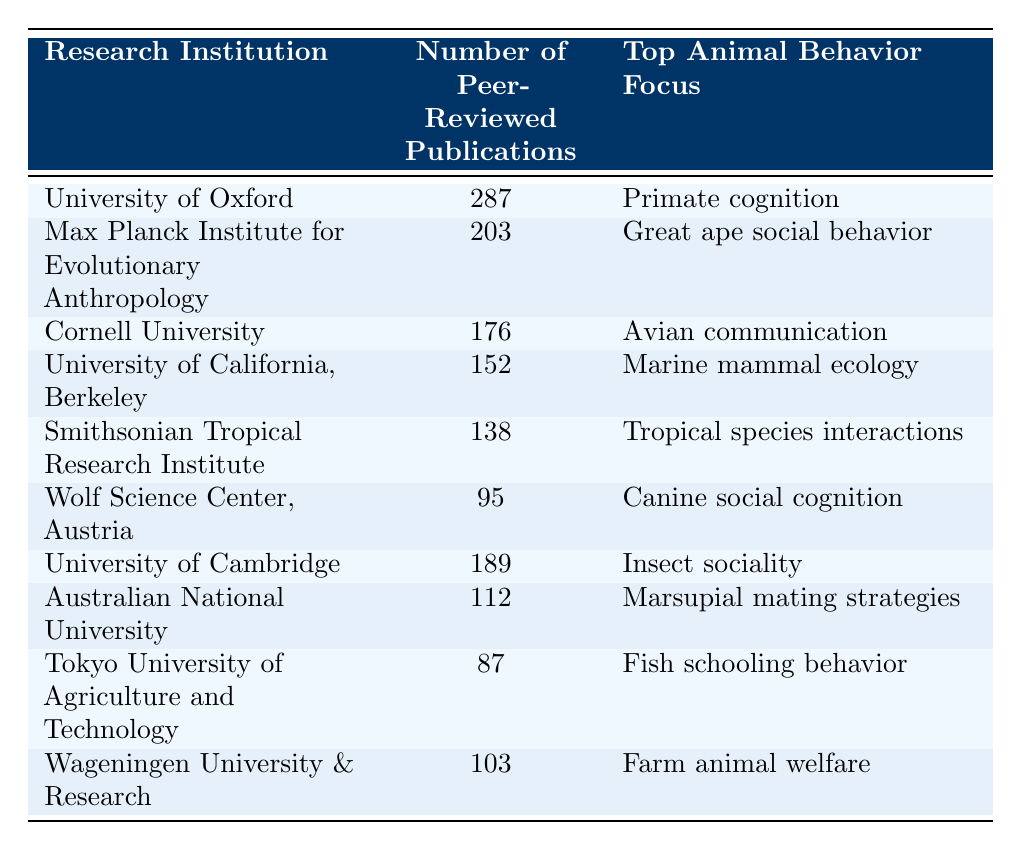What is the top animal behavior focus of the University of Oxford? The table shows that the top animal behavior focus listed for the University of Oxford is "Primate cognition."
Answer: Primate cognition How many peer-reviewed publications does Cornell University have? According to the table, Cornell University has 176 peer-reviewed publications listed.
Answer: 176 Which institution has the least number of peer-reviewed publications? By examining the table, it is evident that the Tokyo University of Agriculture and Technology has the least number, with 87 publications.
Answer: Tokyo University of Agriculture and Technology What is the average number of peer-reviewed publications for the institutions listed? To find the average, we sum all the publications: 287 + 203 + 176 + 152 + 138 + 95 + 189 + 112 + 87 + 103 = 1,542. There are 10 institutions, so the average is 1,542 / 10 = 154.2.
Answer: 154.2 Does the institution with the highest number of publications focus on primate behavior? The table indicates that the University of Oxford, which has the highest number of publications (287), focuses on "Primate cognition." Therefore, the statement is true.
Answer: Yes Which institution focuses on marine mammal ecology and how many publications do they have? From the table, the University of California, Berkeley focuses on marine mammal ecology and has 152 peer-reviewed publications.
Answer: University of California, Berkeley; 152 How many institutions focus on insect or fish behavior? The table lists the University of Cambridge focused on insect sociality and the Tokyo University of Agriculture and Technology focused on fish schooling behavior, making a total of 2 institutions.
Answer: 2 Which animal behavior focus is represented by the most publications, and how many are there? The University of Oxford's focus is on primate cognition with 287 publications, which is the highest count of all focuses listed in the table.
Answer: Primate cognition; 287 Is there an institution with a focus on farm animal welfare? The table confirms that Wageningen University & Research focuses on farm animal welfare, therefore the answer is yes.
Answer: Yes 